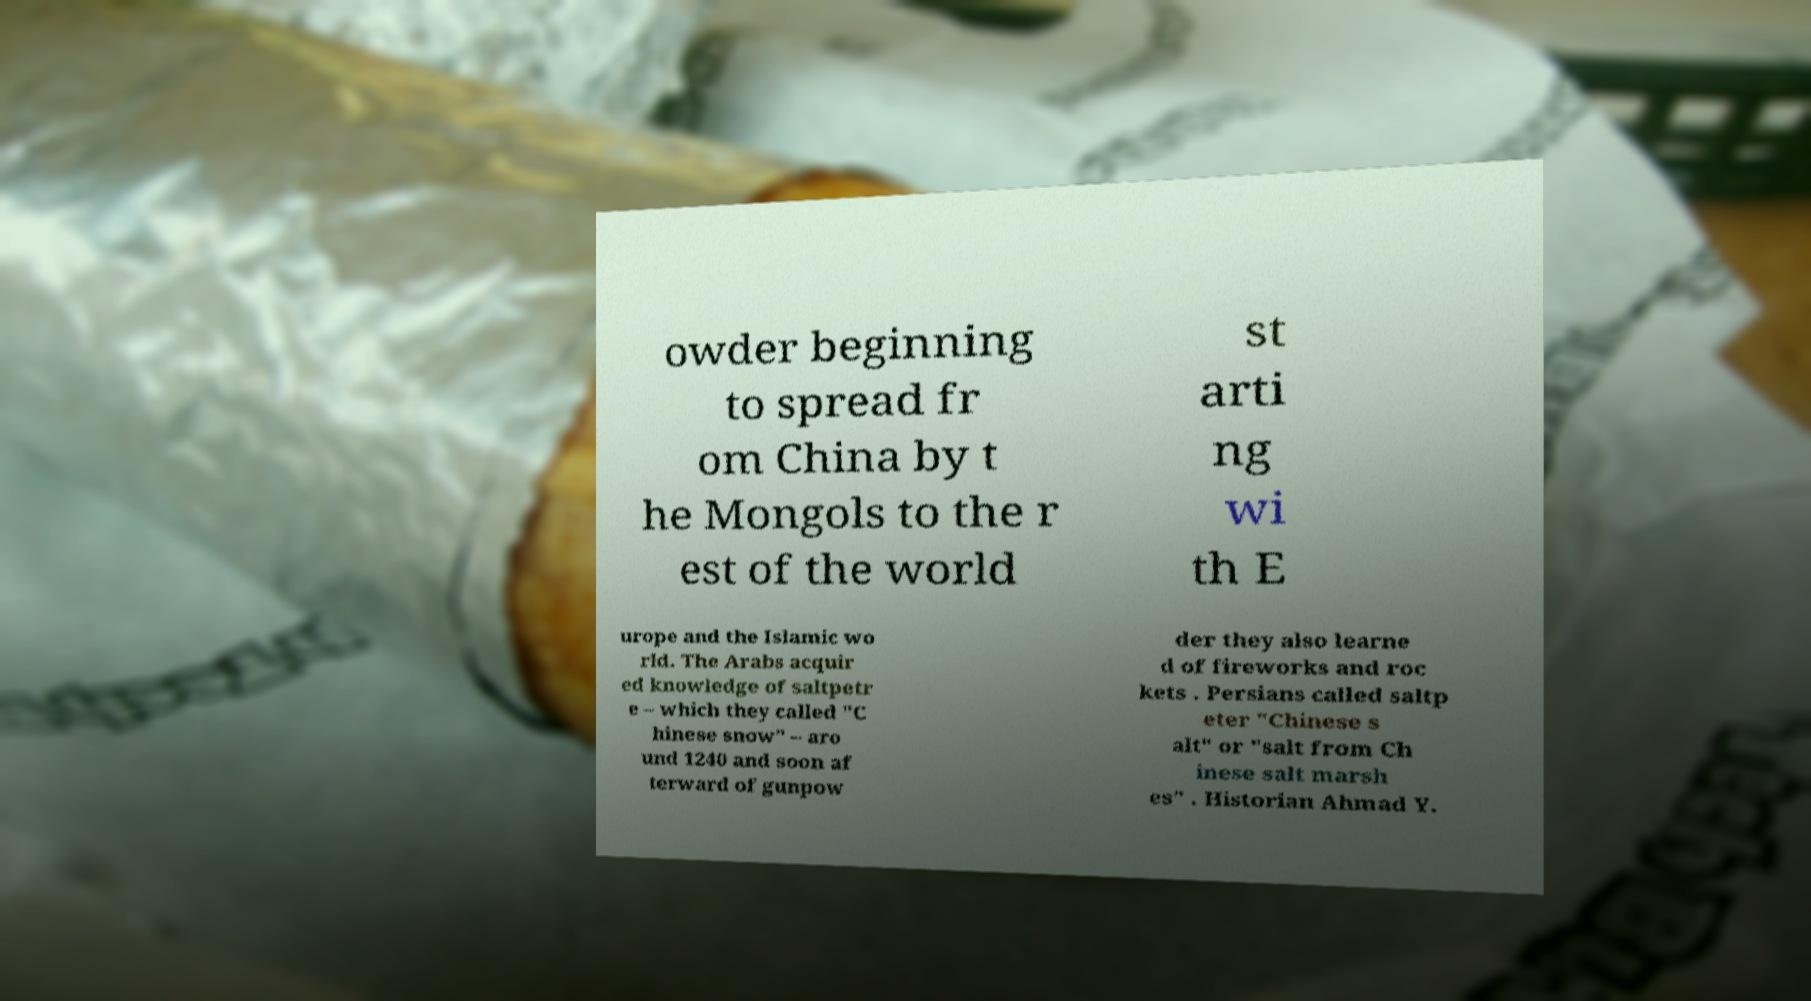There's text embedded in this image that I need extracted. Can you transcribe it verbatim? owder beginning to spread fr om China by t he Mongols to the r est of the world st arti ng wi th E urope and the Islamic wo rld. The Arabs acquir ed knowledge of saltpetr e – which they called "C hinese snow" – aro und 1240 and soon af terward of gunpow der they also learne d of fireworks and roc kets . Persians called saltp eter "Chinese s alt" or "salt from Ch inese salt marsh es" . Historian Ahmad Y. 